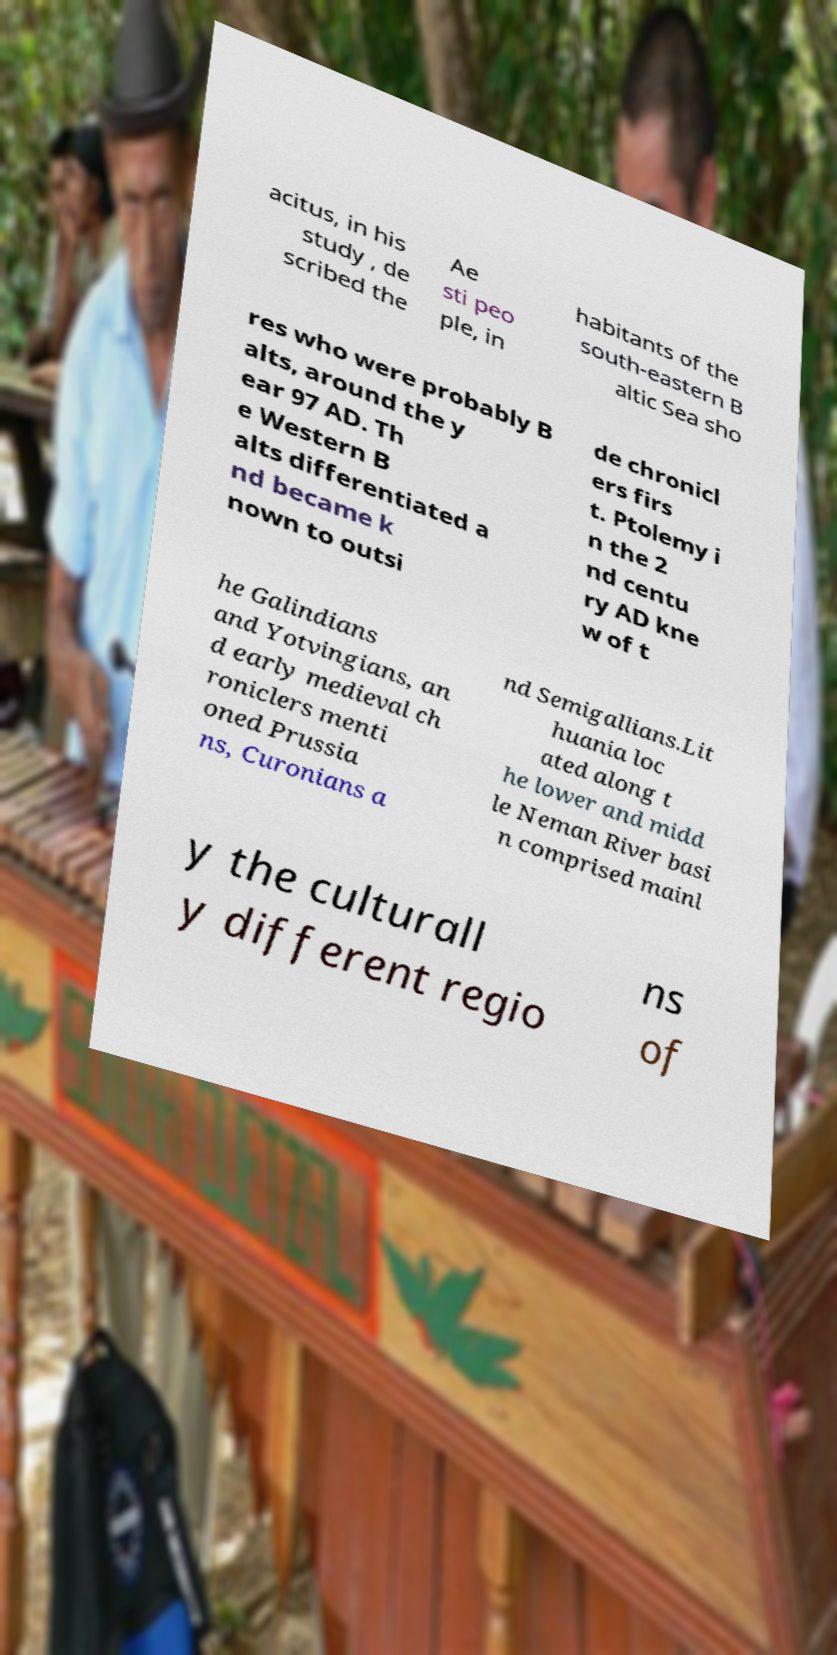What messages or text are displayed in this image? I need them in a readable, typed format. acitus, in his study , de scribed the Ae sti peo ple, in habitants of the south-eastern B altic Sea sho res who were probably B alts, around the y ear 97 AD. Th e Western B alts differentiated a nd became k nown to outsi de chronicl ers firs t. Ptolemy i n the 2 nd centu ry AD kne w of t he Galindians and Yotvingians, an d early medieval ch roniclers menti oned Prussia ns, Curonians a nd Semigallians.Lit huania loc ated along t he lower and midd le Neman River basi n comprised mainl y the culturall y different regio ns of 